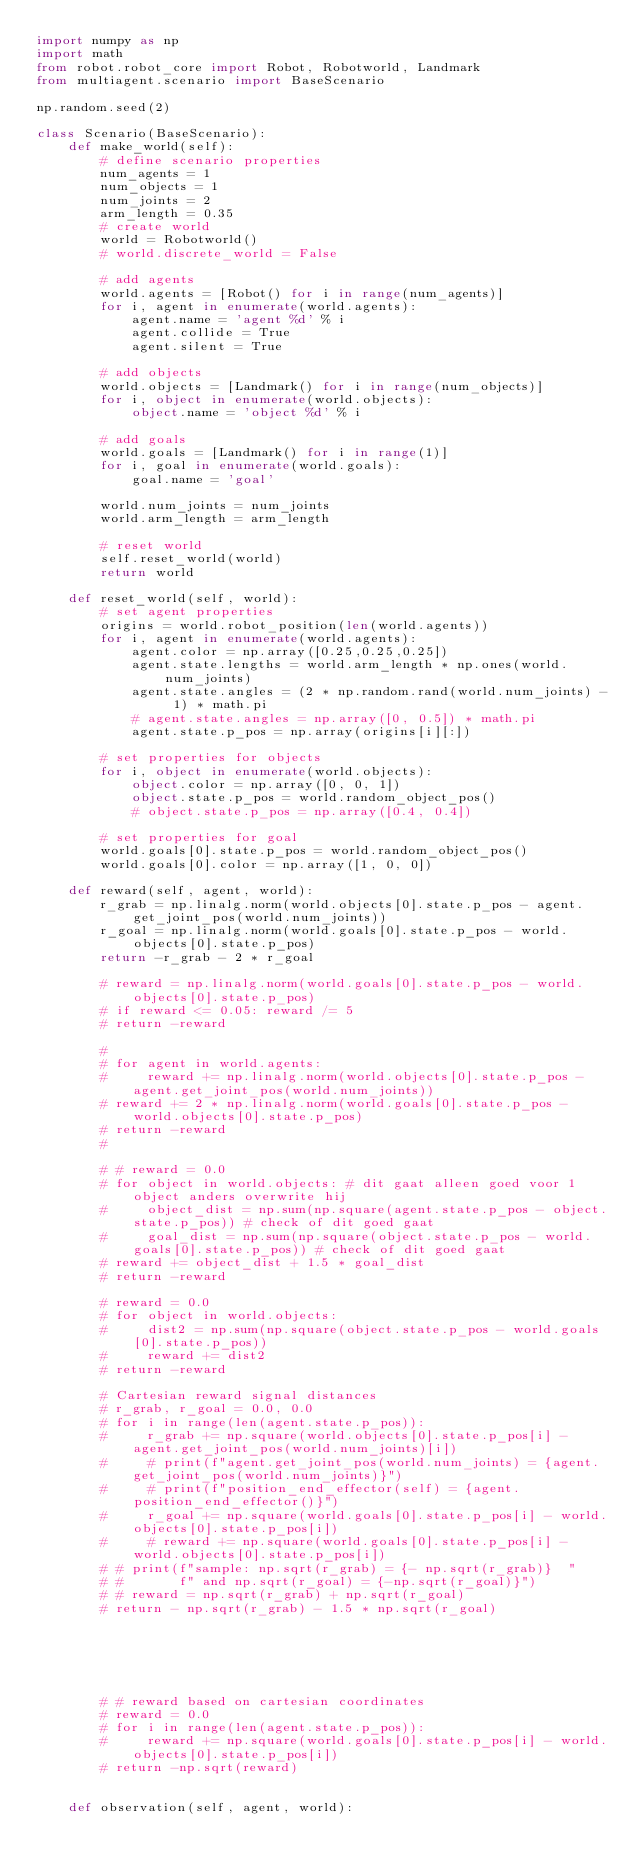Convert code to text. <code><loc_0><loc_0><loc_500><loc_500><_Python_>import numpy as np
import math
from robot.robot_core import Robot, Robotworld, Landmark
from multiagent.scenario import BaseScenario

np.random.seed(2)

class Scenario(BaseScenario):
    def make_world(self):
        # define scenario properties
        num_agents = 1
        num_objects = 1
        num_joints = 2
        arm_length = 0.35
        # create world
        world = Robotworld()
        # world.discrete_world = False

        # add agents
        world.agents = [Robot() for i in range(num_agents)]
        for i, agent in enumerate(world.agents):
            agent.name = 'agent %d' % i
            agent.collide = True
            agent.silent = True

        # add objects
        world.objects = [Landmark() for i in range(num_objects)]
        for i, object in enumerate(world.objects):
            object.name = 'object %d' % i

        # add goals
        world.goals = [Landmark() for i in range(1)]
        for i, goal in enumerate(world.goals):
            goal.name = 'goal'

        world.num_joints = num_joints
        world.arm_length = arm_length

        # reset world
        self.reset_world(world)
        return world

    def reset_world(self, world):
        # set agent properties
        origins = world.robot_position(len(world.agents))
        for i, agent in enumerate(world.agents):
            agent.color = np.array([0.25,0.25,0.25])
            agent.state.lengths = world.arm_length * np.ones(world.num_joints)
            agent.state.angles = (2 * np.random.rand(world.num_joints) - 1) * math.pi
            # agent.state.angles = np.array([0, 0.5]) * math.pi
            agent.state.p_pos = np.array(origins[i][:])

        # set properties for objects
        for i, object in enumerate(world.objects):
            object.color = np.array([0, 0, 1])
            object.state.p_pos = world.random_object_pos()
            # object.state.p_pos = np.array([0.4, 0.4])

        # set properties for goal
        world.goals[0].state.p_pos = world.random_object_pos()
        world.goals[0].color = np.array([1, 0, 0])

    def reward(self, agent, world):
        r_grab = np.linalg.norm(world.objects[0].state.p_pos - agent.get_joint_pos(world.num_joints))
        r_goal = np.linalg.norm(world.goals[0].state.p_pos - world.objects[0].state.p_pos)
        return -r_grab - 2 * r_goal

        # reward = np.linalg.norm(world.goals[0].state.p_pos - world.objects[0].state.p_pos)
        # if reward <= 0.05: reward /= 5
        # return -reward

        #
        # for agent in world.agents:
        #     reward += np.linalg.norm(world.objects[0].state.p_pos - agent.get_joint_pos(world.num_joints))
        # reward += 2 * np.linalg.norm(world.goals[0].state.p_pos - world.objects[0].state.p_pos)
        # return -reward
        #

        # # reward = 0.0
        # for object in world.objects: # dit gaat alleen goed voor 1 object anders overwrite hij
        #     object_dist = np.sum(np.square(agent.state.p_pos - object.state.p_pos)) # check of dit goed gaat
        #     goal_dist = np.sum(np.square(object.state.p_pos - world.goals[0].state.p_pos)) # check of dit goed gaat
        # reward += object_dist + 1.5 * goal_dist
        # return -reward

        # reward = 0.0
        # for object in world.objects:
        #     dist2 = np.sum(np.square(object.state.p_pos - world.goals[0].state.p_pos))
        #     reward += dist2
        # return -reward

        # Cartesian reward signal distances
        # r_grab, r_goal = 0.0, 0.0
        # for i in range(len(agent.state.p_pos)):
        #     r_grab += np.square(world.objects[0].state.p_pos[i] - agent.get_joint_pos(world.num_joints)[i])
        #     # print(f"agent.get_joint_pos(world.num_joints) = {agent.get_joint_pos(world.num_joints)}")
        #     # print(f"position_end_effector(self) = {agent.position_end_effector()}")
        #     r_goal += np.square(world.goals[0].state.p_pos[i] - world.objects[0].state.p_pos[i])
        #     # reward += np.square(world.goals[0].state.p_pos[i] - world.objects[0].state.p_pos[i])
        # # print(f"sample: np.sqrt(r_grab) = {- np.sqrt(r_grab)}  "
        # #       f" and np.sqrt(r_goal) = {-np.sqrt(r_goal)}")
        # # reward = np.sqrt(r_grab) + np.sqrt(r_goal)
        # return - np.sqrt(r_grab) - 1.5 * np.sqrt(r_goal)






        # # reward based on cartesian coordinates
        # reward = 0.0
        # for i in range(len(agent.state.p_pos)):
        #     reward += np.square(world.goals[0].state.p_pos[i] - world.objects[0].state.p_pos[i])
        # return -np.sqrt(reward)


    def observation(self, agent, world):</code> 